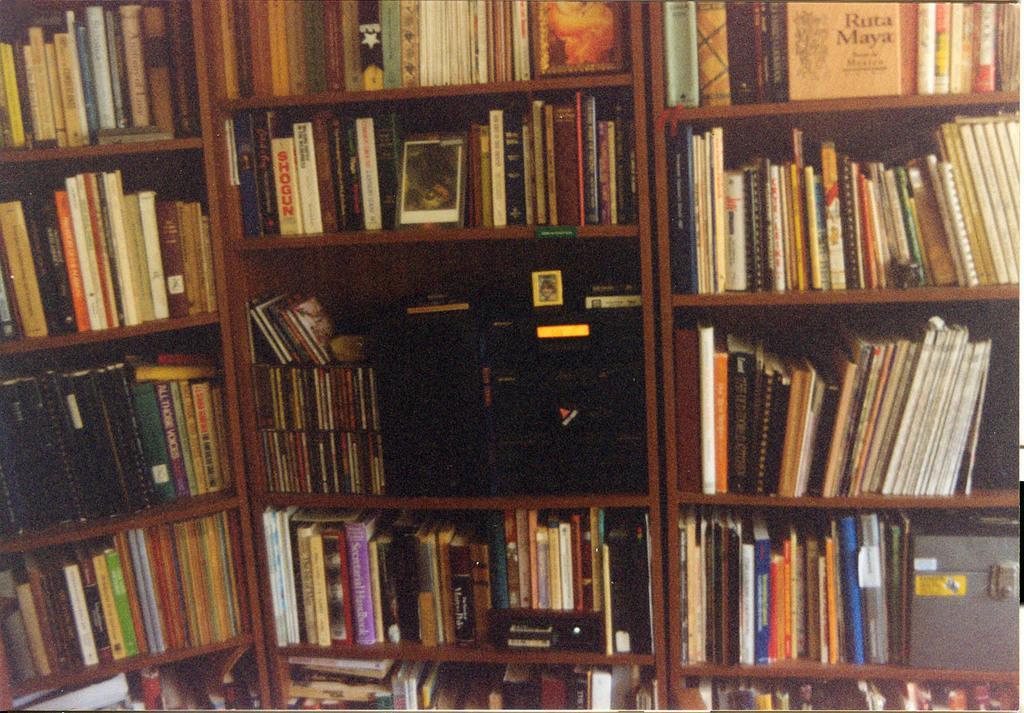Please provide a concise description of this image. In the image there are cupboards with racks. On the racks there are books and also there is a box and a black color object on the rack. 